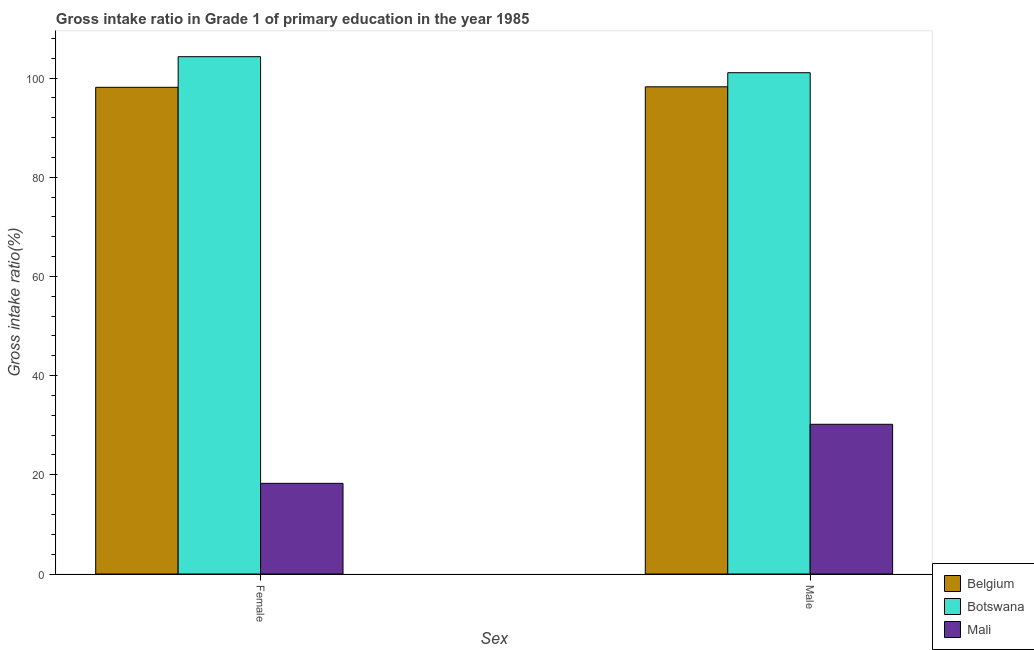How many different coloured bars are there?
Your answer should be compact. 3. How many groups of bars are there?
Keep it short and to the point. 2. Are the number of bars per tick equal to the number of legend labels?
Provide a succinct answer. Yes. How many bars are there on the 2nd tick from the right?
Offer a very short reply. 3. What is the gross intake ratio(female) in Botswana?
Provide a succinct answer. 104.3. Across all countries, what is the maximum gross intake ratio(male)?
Offer a terse response. 101.07. Across all countries, what is the minimum gross intake ratio(male)?
Your answer should be very brief. 30.19. In which country was the gross intake ratio(female) maximum?
Give a very brief answer. Botswana. In which country was the gross intake ratio(male) minimum?
Your response must be concise. Mali. What is the total gross intake ratio(female) in the graph?
Your answer should be compact. 220.72. What is the difference between the gross intake ratio(female) in Mali and that in Botswana?
Offer a very short reply. -86.02. What is the difference between the gross intake ratio(male) in Mali and the gross intake ratio(female) in Botswana?
Your response must be concise. -74.12. What is the average gross intake ratio(female) per country?
Your answer should be very brief. 73.57. What is the difference between the gross intake ratio(male) and gross intake ratio(female) in Belgium?
Your answer should be compact. 0.1. In how many countries, is the gross intake ratio(male) greater than 84 %?
Give a very brief answer. 2. What is the ratio of the gross intake ratio(male) in Mali to that in Belgium?
Your answer should be very brief. 0.31. Is the gross intake ratio(male) in Mali less than that in Belgium?
Ensure brevity in your answer.  Yes. In how many countries, is the gross intake ratio(female) greater than the average gross intake ratio(female) taken over all countries?
Your answer should be compact. 2. What does the 1st bar from the left in Male represents?
Your response must be concise. Belgium. How many bars are there?
Provide a short and direct response. 6. Are all the bars in the graph horizontal?
Your answer should be very brief. No. Are the values on the major ticks of Y-axis written in scientific E-notation?
Offer a terse response. No. How are the legend labels stacked?
Provide a succinct answer. Vertical. What is the title of the graph?
Offer a terse response. Gross intake ratio in Grade 1 of primary education in the year 1985. Does "Monaco" appear as one of the legend labels in the graph?
Give a very brief answer. No. What is the label or title of the X-axis?
Keep it short and to the point. Sex. What is the label or title of the Y-axis?
Offer a terse response. Gross intake ratio(%). What is the Gross intake ratio(%) in Belgium in Female?
Your response must be concise. 98.13. What is the Gross intake ratio(%) in Botswana in Female?
Ensure brevity in your answer.  104.3. What is the Gross intake ratio(%) of Mali in Female?
Ensure brevity in your answer.  18.28. What is the Gross intake ratio(%) in Belgium in Male?
Offer a terse response. 98.23. What is the Gross intake ratio(%) of Botswana in Male?
Ensure brevity in your answer.  101.07. What is the Gross intake ratio(%) in Mali in Male?
Your answer should be compact. 30.19. Across all Sex, what is the maximum Gross intake ratio(%) in Belgium?
Provide a succinct answer. 98.23. Across all Sex, what is the maximum Gross intake ratio(%) in Botswana?
Give a very brief answer. 104.3. Across all Sex, what is the maximum Gross intake ratio(%) of Mali?
Give a very brief answer. 30.19. Across all Sex, what is the minimum Gross intake ratio(%) of Belgium?
Ensure brevity in your answer.  98.13. Across all Sex, what is the minimum Gross intake ratio(%) of Botswana?
Ensure brevity in your answer.  101.07. Across all Sex, what is the minimum Gross intake ratio(%) in Mali?
Provide a short and direct response. 18.28. What is the total Gross intake ratio(%) in Belgium in the graph?
Your response must be concise. 196.36. What is the total Gross intake ratio(%) in Botswana in the graph?
Ensure brevity in your answer.  205.37. What is the total Gross intake ratio(%) of Mali in the graph?
Give a very brief answer. 48.47. What is the difference between the Gross intake ratio(%) in Belgium in Female and that in Male?
Your answer should be very brief. -0.1. What is the difference between the Gross intake ratio(%) in Botswana in Female and that in Male?
Offer a very short reply. 3.23. What is the difference between the Gross intake ratio(%) of Mali in Female and that in Male?
Ensure brevity in your answer.  -11.9. What is the difference between the Gross intake ratio(%) of Belgium in Female and the Gross intake ratio(%) of Botswana in Male?
Provide a succinct answer. -2.94. What is the difference between the Gross intake ratio(%) of Belgium in Female and the Gross intake ratio(%) of Mali in Male?
Provide a short and direct response. 67.94. What is the difference between the Gross intake ratio(%) in Botswana in Female and the Gross intake ratio(%) in Mali in Male?
Your answer should be very brief. 74.12. What is the average Gross intake ratio(%) of Belgium per Sex?
Offer a terse response. 98.18. What is the average Gross intake ratio(%) in Botswana per Sex?
Your answer should be compact. 102.69. What is the average Gross intake ratio(%) of Mali per Sex?
Your answer should be compact. 24.23. What is the difference between the Gross intake ratio(%) of Belgium and Gross intake ratio(%) of Botswana in Female?
Offer a terse response. -6.17. What is the difference between the Gross intake ratio(%) of Belgium and Gross intake ratio(%) of Mali in Female?
Your answer should be compact. 79.85. What is the difference between the Gross intake ratio(%) of Botswana and Gross intake ratio(%) of Mali in Female?
Your response must be concise. 86.02. What is the difference between the Gross intake ratio(%) of Belgium and Gross intake ratio(%) of Botswana in Male?
Ensure brevity in your answer.  -2.84. What is the difference between the Gross intake ratio(%) of Belgium and Gross intake ratio(%) of Mali in Male?
Offer a terse response. 68.04. What is the difference between the Gross intake ratio(%) of Botswana and Gross intake ratio(%) of Mali in Male?
Your answer should be very brief. 70.89. What is the ratio of the Gross intake ratio(%) of Botswana in Female to that in Male?
Offer a very short reply. 1.03. What is the ratio of the Gross intake ratio(%) in Mali in Female to that in Male?
Your response must be concise. 0.61. What is the difference between the highest and the second highest Gross intake ratio(%) of Belgium?
Your response must be concise. 0.1. What is the difference between the highest and the second highest Gross intake ratio(%) in Botswana?
Give a very brief answer. 3.23. What is the difference between the highest and the second highest Gross intake ratio(%) in Mali?
Provide a succinct answer. 11.9. What is the difference between the highest and the lowest Gross intake ratio(%) of Belgium?
Keep it short and to the point. 0.1. What is the difference between the highest and the lowest Gross intake ratio(%) in Botswana?
Offer a very short reply. 3.23. What is the difference between the highest and the lowest Gross intake ratio(%) of Mali?
Keep it short and to the point. 11.9. 